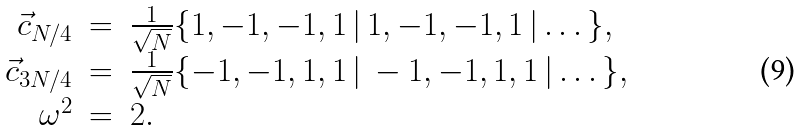Convert formula to latex. <formula><loc_0><loc_0><loc_500><loc_500>\begin{array} { r c l } \vec { c } _ { N / 4 } & = & \frac { 1 } { \sqrt { N } } \{ 1 , - 1 , - 1 , 1 \, | \, 1 , - 1 , - 1 , 1 \, | \dots \} , \\ \vec { c } _ { 3 N / 4 } & = & \frac { 1 } { \sqrt { N } } \{ - 1 , - 1 , 1 , 1 \, | \, - 1 , - 1 , 1 , 1 \, | \dots \} , \\ \omega ^ { 2 } & = & 2 . \end{array}</formula> 